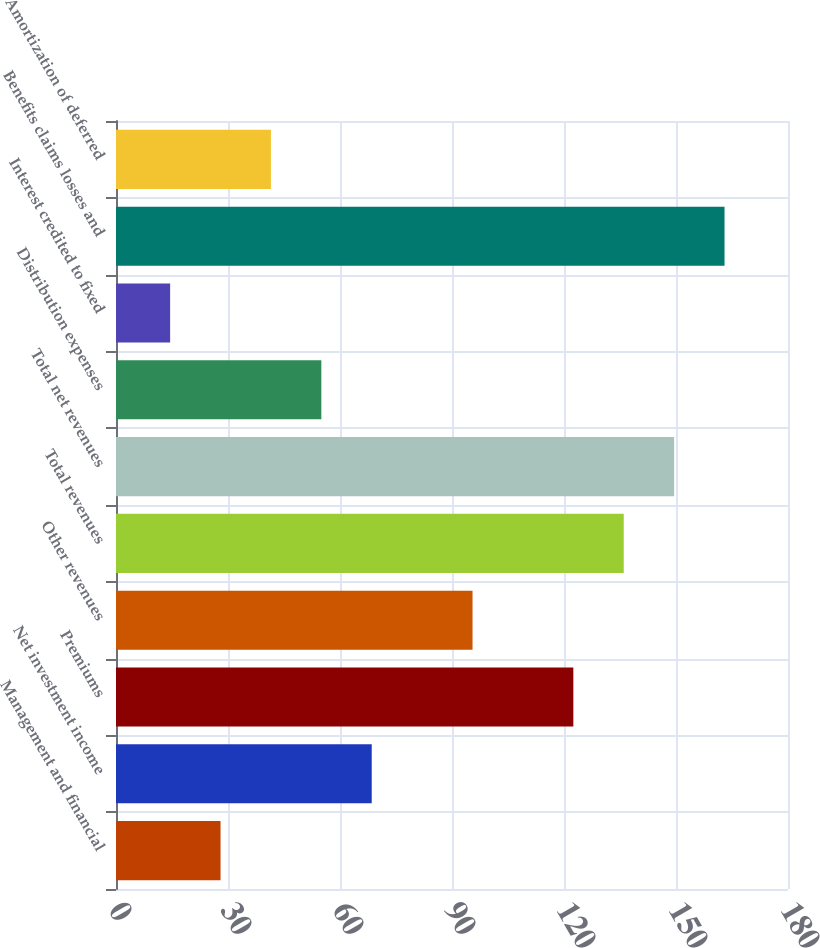Convert chart. <chart><loc_0><loc_0><loc_500><loc_500><bar_chart><fcel>Management and financial<fcel>Net investment income<fcel>Premiums<fcel>Other revenues<fcel>Total revenues<fcel>Total net revenues<fcel>Distribution expenses<fcel>Interest credited to fixed<fcel>Benefits claims losses and<fcel>Amortization of deferred<nl><fcel>28<fcel>68.5<fcel>122.5<fcel>95.5<fcel>136<fcel>149.5<fcel>55<fcel>14.5<fcel>163<fcel>41.5<nl></chart> 